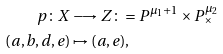Convert formula to latex. <formula><loc_0><loc_0><loc_500><loc_500>p \colon X & \longrightarrow Z \colon = P ^ { \mu _ { 1 } + 1 } \times P ^ { \mu _ { 2 } } _ { \times } \\ ( a , b , d , e ) & \mapsto ( a , e ) ,</formula> 